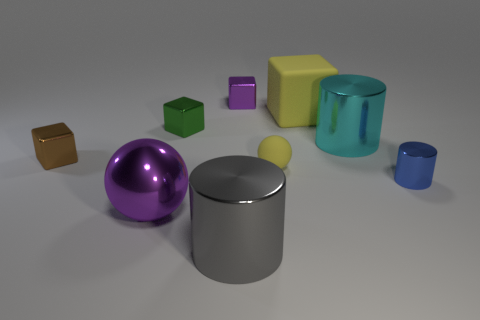How many blue objects are either small metallic cylinders or matte blocks? 1 